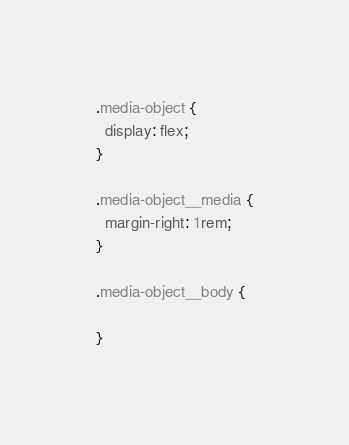<code> <loc_0><loc_0><loc_500><loc_500><_CSS_>.media-object {
  display: flex;
}

.media-object__media {
  margin-right: 1rem;
}

.media-object__body {

}
</code> 